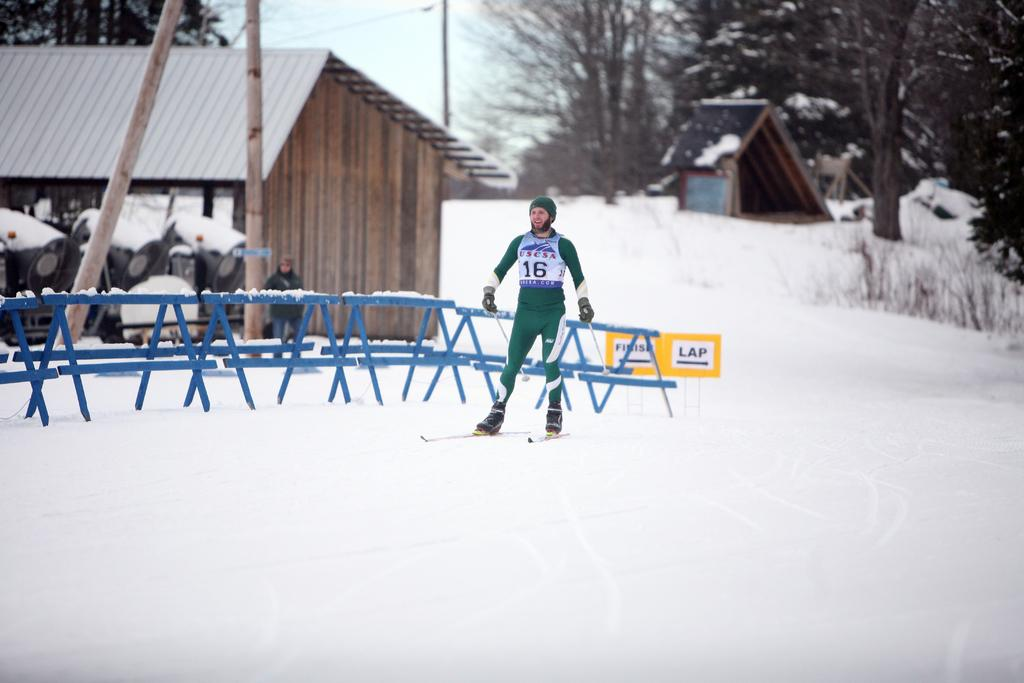Who is the person in the image? There is a man in the image. What is the man doing in the image? The man is skating on snow. What can be seen in the background of the image? There are sheds, fencing, trees, and poles in the background of the image. What invention is the man using to sleep in the image? There is no invention for sleeping present in the image, and the man is not depicted as sleeping. 